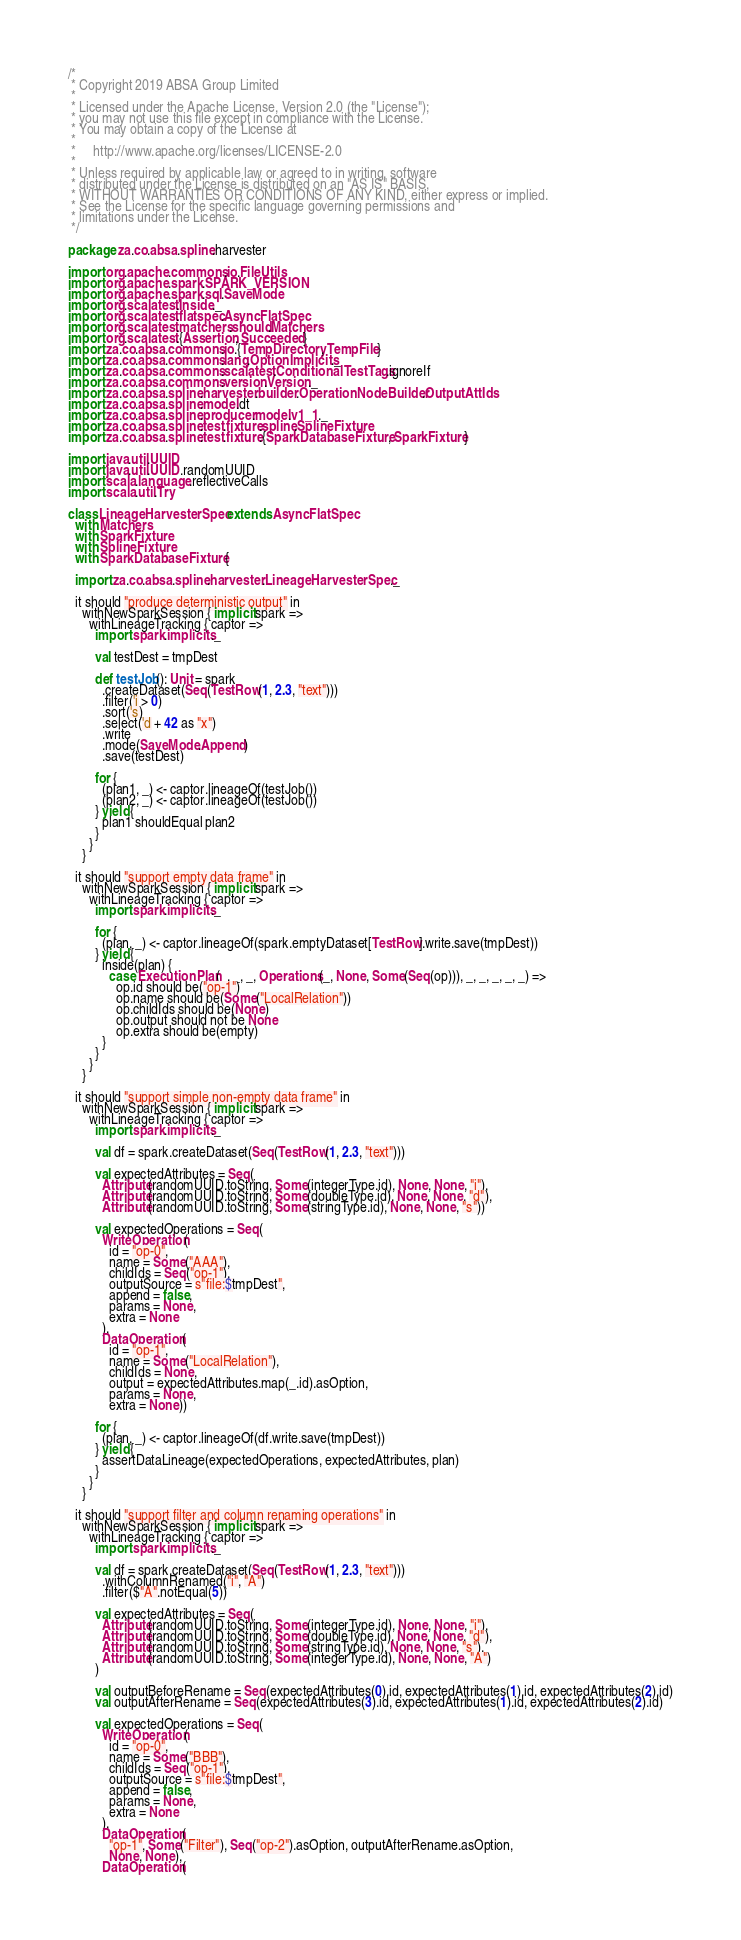<code> <loc_0><loc_0><loc_500><loc_500><_Scala_>/*
 * Copyright 2019 ABSA Group Limited
 *
 * Licensed under the Apache License, Version 2.0 (the "License");
 * you may not use this file except in compliance with the License.
 * You may obtain a copy of the License at
 *
 *     http://www.apache.org/licenses/LICENSE-2.0
 *
 * Unless required by applicable law or agreed to in writing, software
 * distributed under the License is distributed on an "AS IS" BASIS,
 * WITHOUT WARRANTIES OR CONDITIONS OF ANY KIND, either express or implied.
 * See the License for the specific language governing permissions and
 * limitations under the License.
 */

package za.co.absa.spline.harvester

import org.apache.commons.io.FileUtils
import org.apache.spark.SPARK_VERSION
import org.apache.spark.sql.SaveMode
import org.scalatest.Inside._
import org.scalatest.flatspec.AsyncFlatSpec
import org.scalatest.matchers.should.Matchers
import org.scalatest.{Assertion, Succeeded}
import za.co.absa.commons.io.{TempDirectory, TempFile}
import za.co.absa.commons.lang.OptionImplicits._
import za.co.absa.commons.scalatest.ConditionalTestTags.ignoreIf
import za.co.absa.commons.version.Version._
import za.co.absa.spline.harvester.builder.OperationNodeBuilder.OutputAttIds
import za.co.absa.spline.model.dt
import za.co.absa.spline.producer.model.v1_1._
import za.co.absa.spline.test.fixture.spline.SplineFixture
import za.co.absa.spline.test.fixture.{SparkDatabaseFixture, SparkFixture}

import java.util.UUID
import java.util.UUID.randomUUID
import scala.language.reflectiveCalls
import scala.util.Try

class LineageHarvesterSpec extends AsyncFlatSpec
  with Matchers
  with SparkFixture
  with SplineFixture
  with SparkDatabaseFixture {

  import za.co.absa.spline.harvester.LineageHarvesterSpec._

  it should "produce deterministic output" in
    withNewSparkSession { implicit spark =>
      withLineageTracking { captor =>
        import spark.implicits._

        val testDest = tmpDest

        def testJob(): Unit = spark
          .createDataset(Seq(TestRow(1, 2.3, "text")))
          .filter('i > 0)
          .sort('s)
          .select('d + 42 as "x")
          .write
          .mode(SaveMode.Append)
          .save(testDest)

        for {
          (plan1, _) <- captor.lineageOf(testJob())
          (plan2, _) <- captor.lineageOf(testJob())
        } yield {
          plan1 shouldEqual plan2
        }
      }
    }

  it should "support empty data frame" in
    withNewSparkSession { implicit spark =>
      withLineageTracking { captor =>
        import spark.implicits._

        for {
          (plan, _) <- captor.lineageOf(spark.emptyDataset[TestRow].write.save(tmpDest))
        } yield {
          inside(plan) {
            case ExecutionPlan(_, _, _, Operations(_, None, Some(Seq(op))), _, _, _, _, _) =>
              op.id should be("op-1")
              op.name should be(Some("LocalRelation"))
              op.childIds should be(None)
              op.output should not be None
              op.extra should be(empty)
          }
        }
      }
    }

  it should "support simple non-empty data frame" in
    withNewSparkSession { implicit spark =>
      withLineageTracking { captor =>
        import spark.implicits._

        val df = spark.createDataset(Seq(TestRow(1, 2.3, "text")))

        val expectedAttributes = Seq(
          Attribute(randomUUID.toString, Some(integerType.id), None, None, "i"),
          Attribute(randomUUID.toString, Some(doubleType.id), None, None, "d"),
          Attribute(randomUUID.toString, Some(stringType.id), None, None, "s"))

        val expectedOperations = Seq(
          WriteOperation(
            id = "op-0",
            name = Some("AAA"),
            childIds = Seq("op-1"),
            outputSource = s"file:$tmpDest",
            append = false,
            params = None,
            extra = None
          ),
          DataOperation(
            id = "op-1",
            name = Some("LocalRelation"),
            childIds = None,
            output = expectedAttributes.map(_.id).asOption,
            params = None,
            extra = None))

        for {
          (plan, _) <- captor.lineageOf(df.write.save(tmpDest))
        } yield {
          assertDataLineage(expectedOperations, expectedAttributes, plan)
        }
      }
    }

  it should "support filter and column renaming operations" in
    withNewSparkSession { implicit spark =>
      withLineageTracking { captor =>
        import spark.implicits._

        val df = spark.createDataset(Seq(TestRow(1, 2.3, "text")))
          .withColumnRenamed("i", "A")
          .filter($"A".notEqual(5))

        val expectedAttributes = Seq(
          Attribute(randomUUID.toString, Some(integerType.id), None, None, "i"),
          Attribute(randomUUID.toString, Some(doubleType.id), None, None, "d"),
          Attribute(randomUUID.toString, Some(stringType.id), None, None, "s"),
          Attribute(randomUUID.toString, Some(integerType.id), None, None, "A")
        )

        val outputBeforeRename = Seq(expectedAttributes(0).id, expectedAttributes(1).id, expectedAttributes(2).id)
        val outputAfterRename = Seq(expectedAttributes(3).id, expectedAttributes(1).id, expectedAttributes(2).id)

        val expectedOperations = Seq(
          WriteOperation(
            id = "op-0",
            name = Some("BBB"),
            childIds = Seq("op-1"),
            outputSource = s"file:$tmpDest",
            append = false,
            params = None,
            extra = None
          ),
          DataOperation(
            "op-1", Some("Filter"), Seq("op-2").asOption, outputAfterRename.asOption,
            None, None),
          DataOperation(</code> 